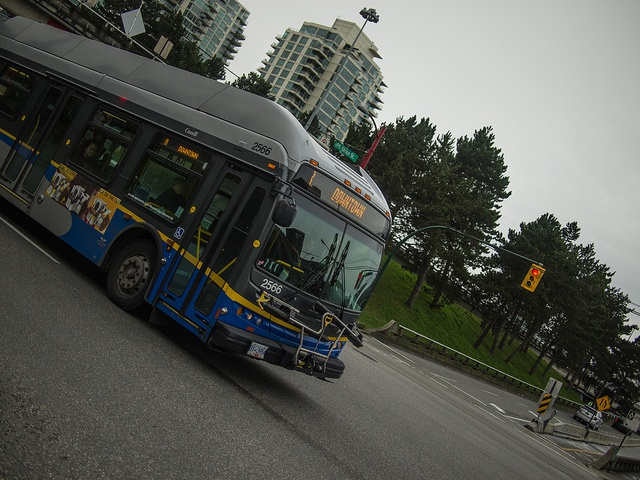Describe the objects in this image and their specific colors. I can see bus in black, gray, navy, and olive tones, people in black, gray, and olive tones, people in black, teal, and darkgreen tones, people in black tones, and car in black, gray, darkgray, and darkgreen tones in this image. 